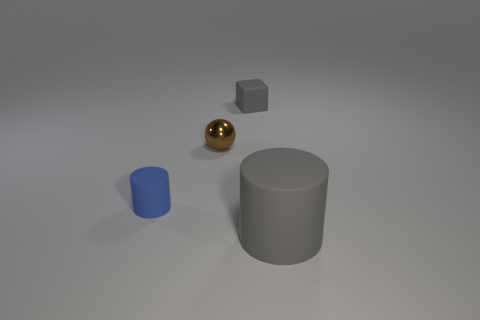There is another rubber object that is the same color as the big thing; what size is it?
Ensure brevity in your answer.  Small. How many other objects are the same shape as the blue matte object?
Your answer should be compact. 1. Are there fewer big yellow metallic things than blue matte things?
Ensure brevity in your answer.  Yes. There is a object that is behind the small cylinder and right of the small brown metal thing; what is its size?
Your response must be concise. Small. What is the size of the gray matte thing that is to the left of the gray matte object in front of the gray matte thing on the left side of the large cylinder?
Give a very brief answer. Small. The ball is what size?
Provide a short and direct response. Small. Are there any other things that are made of the same material as the tiny gray object?
Make the answer very short. Yes. There is a cylinder that is left of the matte cylinder that is on the right side of the block; are there any tiny blue things to the right of it?
Make the answer very short. No. What number of small objects are either gray rubber objects or shiny things?
Make the answer very short. 2. Is there any other thing that has the same color as the tiny ball?
Your response must be concise. No. 